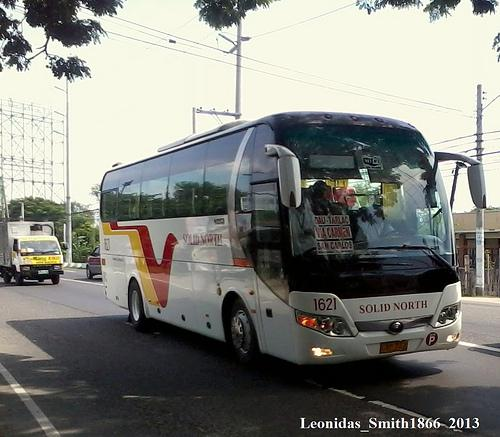Question: who drives the bus?
Choices:
A. Bus driver.
B. A child.
C. Grandma.
D. The principle.
Answer with the letter. Answer: A Question: why do people ride busses?
Choices:
A. They are fast.
B. They carry many people.
C. Transportation.
D. They have a lot of room.
Answer with the letter. Answer: C Question: what number is on the front of the bus?
Choices:
A. Sixteen twenty-one.
B. Twenty five.
C. Nine.
D. Twelve thirty.
Answer with the letter. Answer: A Question: where was this image taken?
Choices:
A. On the highway.
B. On the road.
C. On the mountain.
D. On the street.
Answer with the letter. Answer: D 